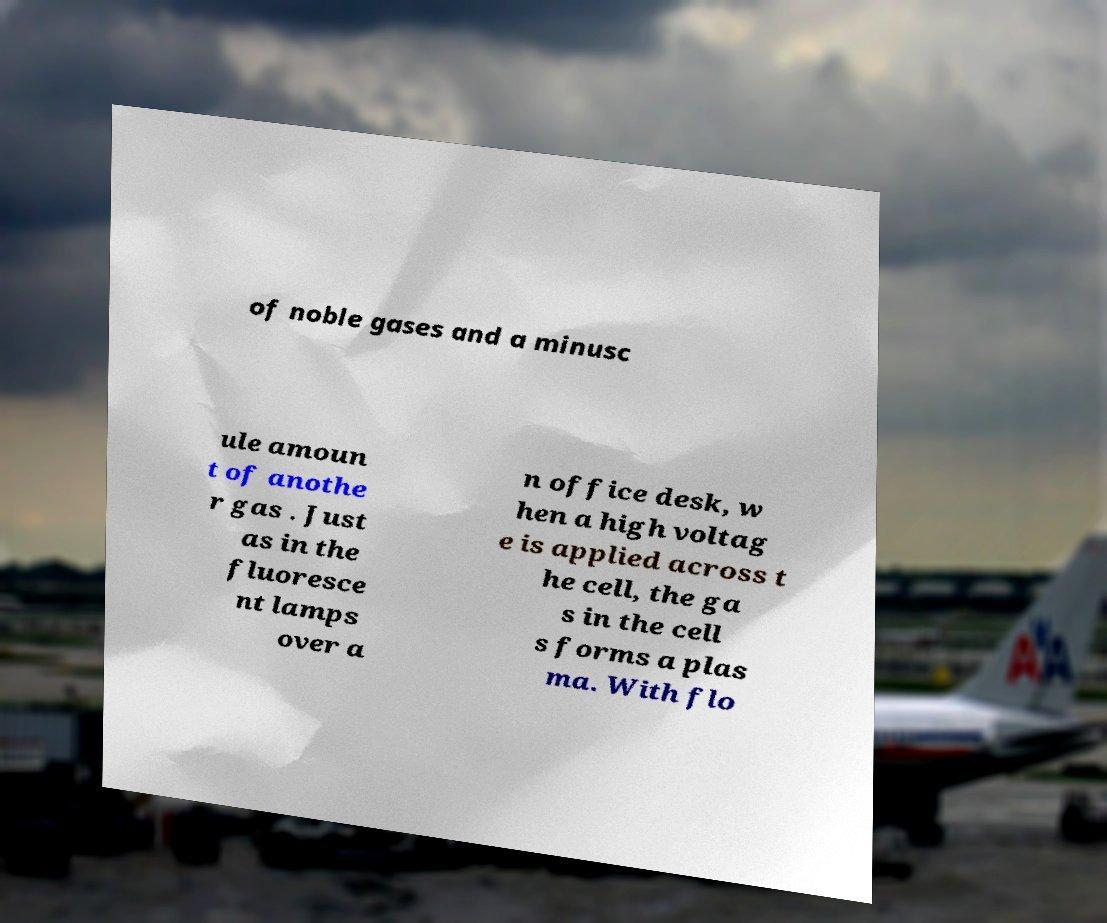I need the written content from this picture converted into text. Can you do that? of noble gases and a minusc ule amoun t of anothe r gas . Just as in the fluoresce nt lamps over a n office desk, w hen a high voltag e is applied across t he cell, the ga s in the cell s forms a plas ma. With flo 